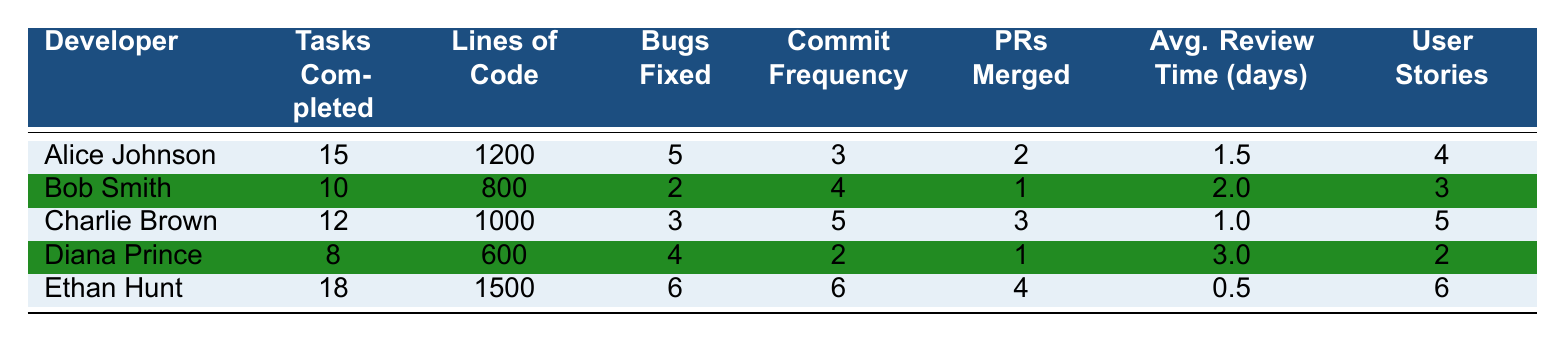What is the maximum number of tasks completed by a developer? To determine the maximum number of tasks completed, we can look at the "Tasks Completed" column. The values are 15, 10, 12, 8, and 18. The highest value among these is 18, which corresponds to Ethan Hunt.
Answer: 18 How many lines of code did Alice Johnson write? We can find this by looking at the row for Alice Johnson in the "Lines of Code" column, which shows 1200 lines.
Answer: 1200 Did any developer fix more than 5 bugs? Looking at the "Bugs Fixed" column, the values are 5, 2, 3, 4, and 6. The only developer who fixed more than 5 bugs is Ethan Hunt, with 6 bugs fixed.
Answer: Yes What is the average number of pull requests merged by all developers? First, we find the total pull requests merged by adding the values in the "PRs Merged" column: 2 + 1 + 3 + 1 + 4 = 11. There are 5 developers, so the average is 11 / 5 = 2.2.
Answer: 2.2 Which developer had the lowest average review time? To find the developer with the lowest average review time, we look at the "Avg. Review Time (days)" column: 1.5, 2.0, 1.0, 3.0, and 0.5. The lowest value is 0.5, which corresponds to Ethan Hunt.
Answer: Ethan Hunt What is the total number of user stories accepted across all developers? We can find the total number of user stories accepted by summing the values in the "User Stories" column: 4 + 3 + 5 + 2 + 6 = 20.
Answer: 20 Is there a developer who completed exactly 10 tasks? Referring to the "Tasks Completed" column, the values are 15, 10, 12, 8, and 18. Bob Smith is the only developer with exactly 10 tasks completed.
Answer: Yes How many more lines of code did Ethan Hunt write compared to Diana Prince? We find the lines of code written by both developers: Ethan Hunt wrote 1500 lines, and Diana Prince wrote 600 lines. The difference is 1500 - 600 = 900.
Answer: 900 